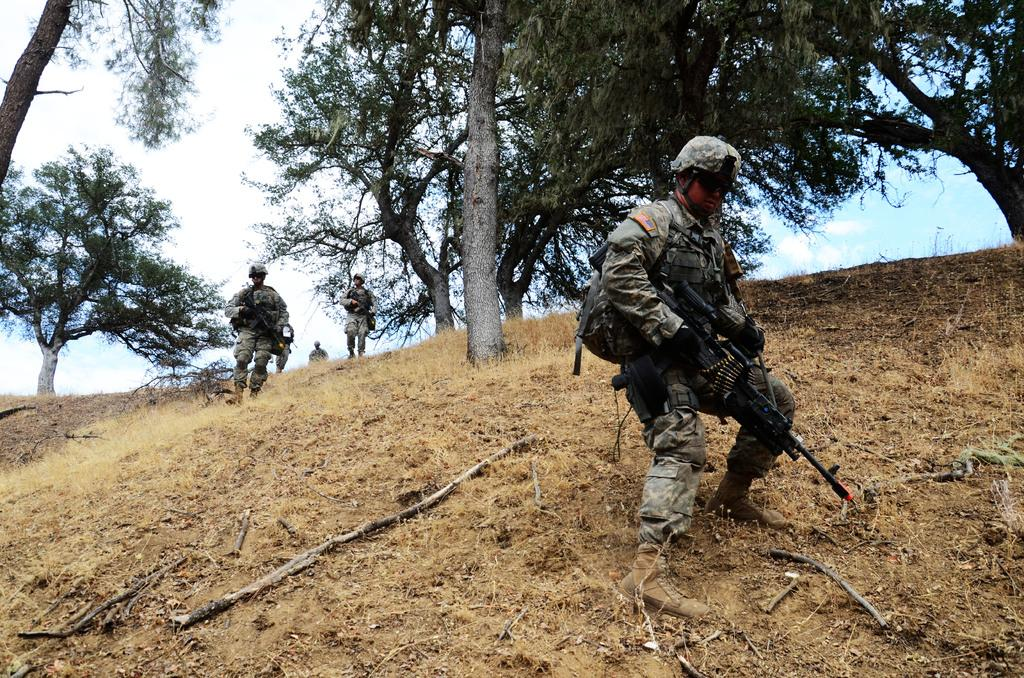What type of natural elements can be seen in the image? There are trees in the image. What part of the natural environment is visible in the image? The sky is visible in the image. What is the person in the image carrying? The person is carrying a gun in the image. What type of protective gear is the person wearing? The person is wearing a helmet. What is visible on the ground in the image? The ground is visible in the image. What type of ornament is hanging from the trees in the image? There is no ornament hanging from the trees in the image; only trees, the sky, a person carrying a gun, a helmet, and the ground are visible. 